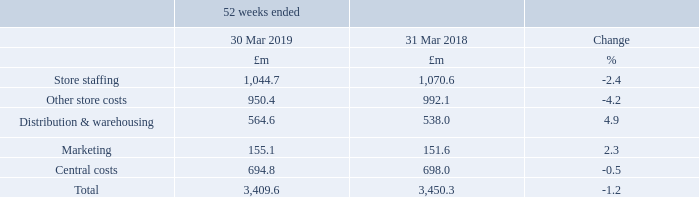UK OPERATING COSTS
UK operating costs decreased 1.2%. Store closures more than offset the cost of new space and channel shift. Cost savings across the business outweighed inflation related increases.
Store staffing costs reduced, as savings from store management restructuring, closures and other efficiencies more than offset pay inflation. Other store costs reduced driven by lower depreciation, due to our closure programme and as a number of assets have reached the end of their useful life, which more than offset rent and rates inflation in the year.
The growth in distribution and warehousing costs was largely driven by inflation and the costs of channel shift, as well as costs associated with the closure of an equipment warehouse, with some offset achieved from improved efficiencies at Castle Donington.
The increase in marketing costs reflected investments in our Food brand and the planned increase in costs in the second half of the year due to the timing of campaigns.
Central costs reduced as lower incentive costs year-on-year, the benefits of technology transformation programmes and other cost efficiencies more than offset system investment write offs and expenditure on the Fuse programme.
What is the operating costs of store staffing in 2019 and 2018 respectively?
Answer scale should be: million. 1,044.7, 1,070.6. What is the operating costs of Other store costs in 2019 and 2018 respectively?
Answer scale should be: million. 950.4, 992.1. What is the operating costs of Distribution & warehousing in 2019 and 2018 respectively?
Answer scale should be: million. 564.6, 538.0. Which year had a higher operating costs of store staffing? 1,070.6> 1,044.7
Answer: 2018. What is the change in Marketing costs between 2018 and 2019?
Answer scale should be: million. 155.1-151.6
Answer: 3.5. What is the average marketing costs for 2018 and 2019?
Answer scale should be: million. (155.1+ 151.6)/2
Answer: 153.35. 